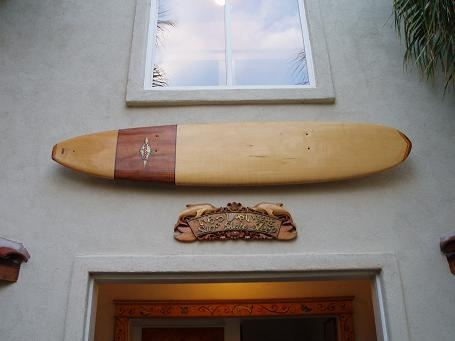Describe the objects in this image and their specific colors. I can see a surfboard in black, tan, gray, and maroon tones in this image. 